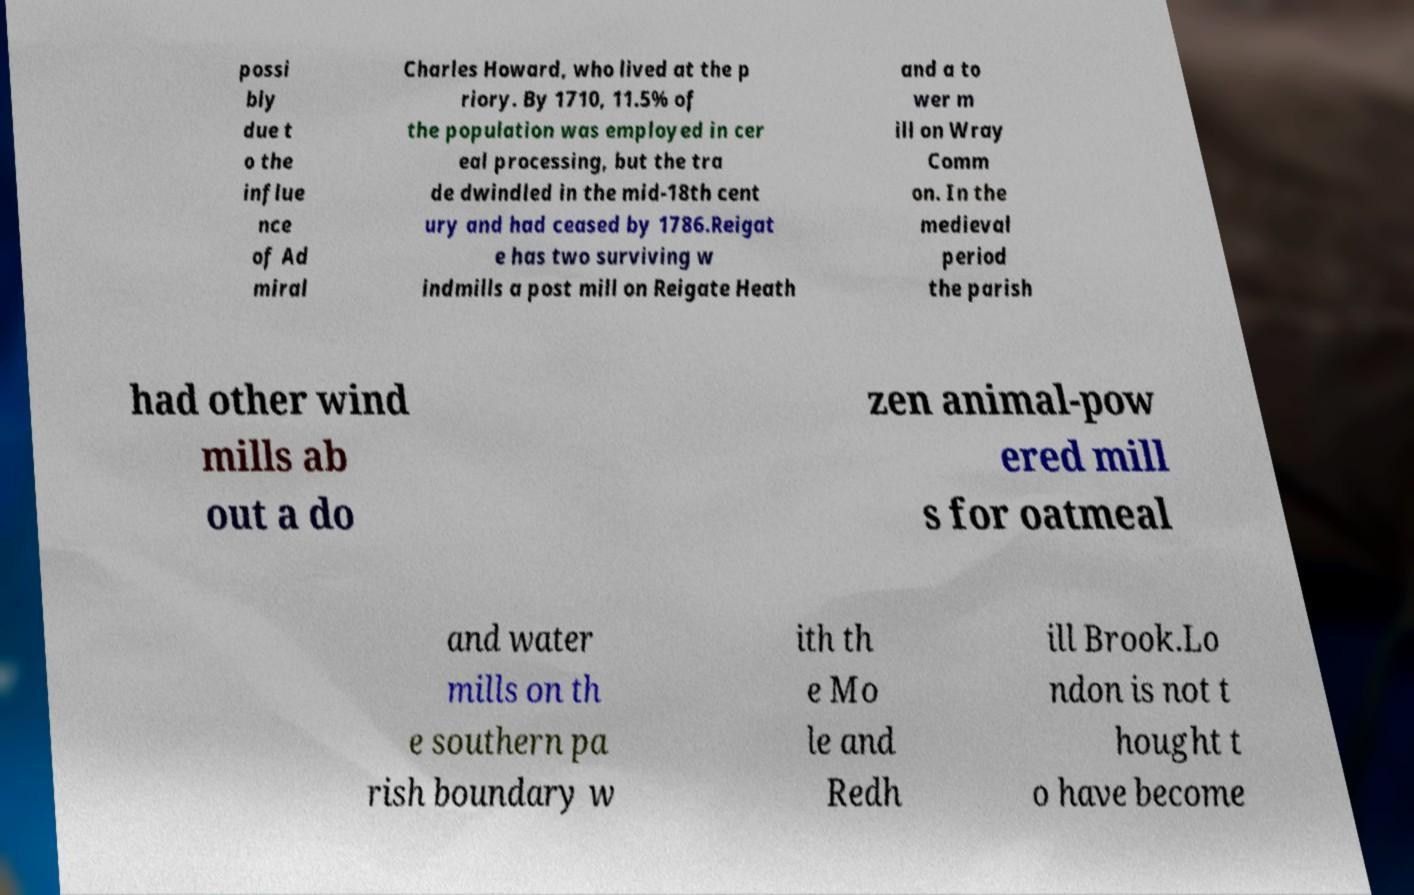Can you read and provide the text displayed in the image?This photo seems to have some interesting text. Can you extract and type it out for me? possi bly due t o the influe nce of Ad miral Charles Howard, who lived at the p riory. By 1710, 11.5% of the population was employed in cer eal processing, but the tra de dwindled in the mid-18th cent ury and had ceased by 1786.Reigat e has two surviving w indmills a post mill on Reigate Heath and a to wer m ill on Wray Comm on. In the medieval period the parish had other wind mills ab out a do zen animal-pow ered mill s for oatmeal and water mills on th e southern pa rish boundary w ith th e Mo le and Redh ill Brook.Lo ndon is not t hought t o have become 